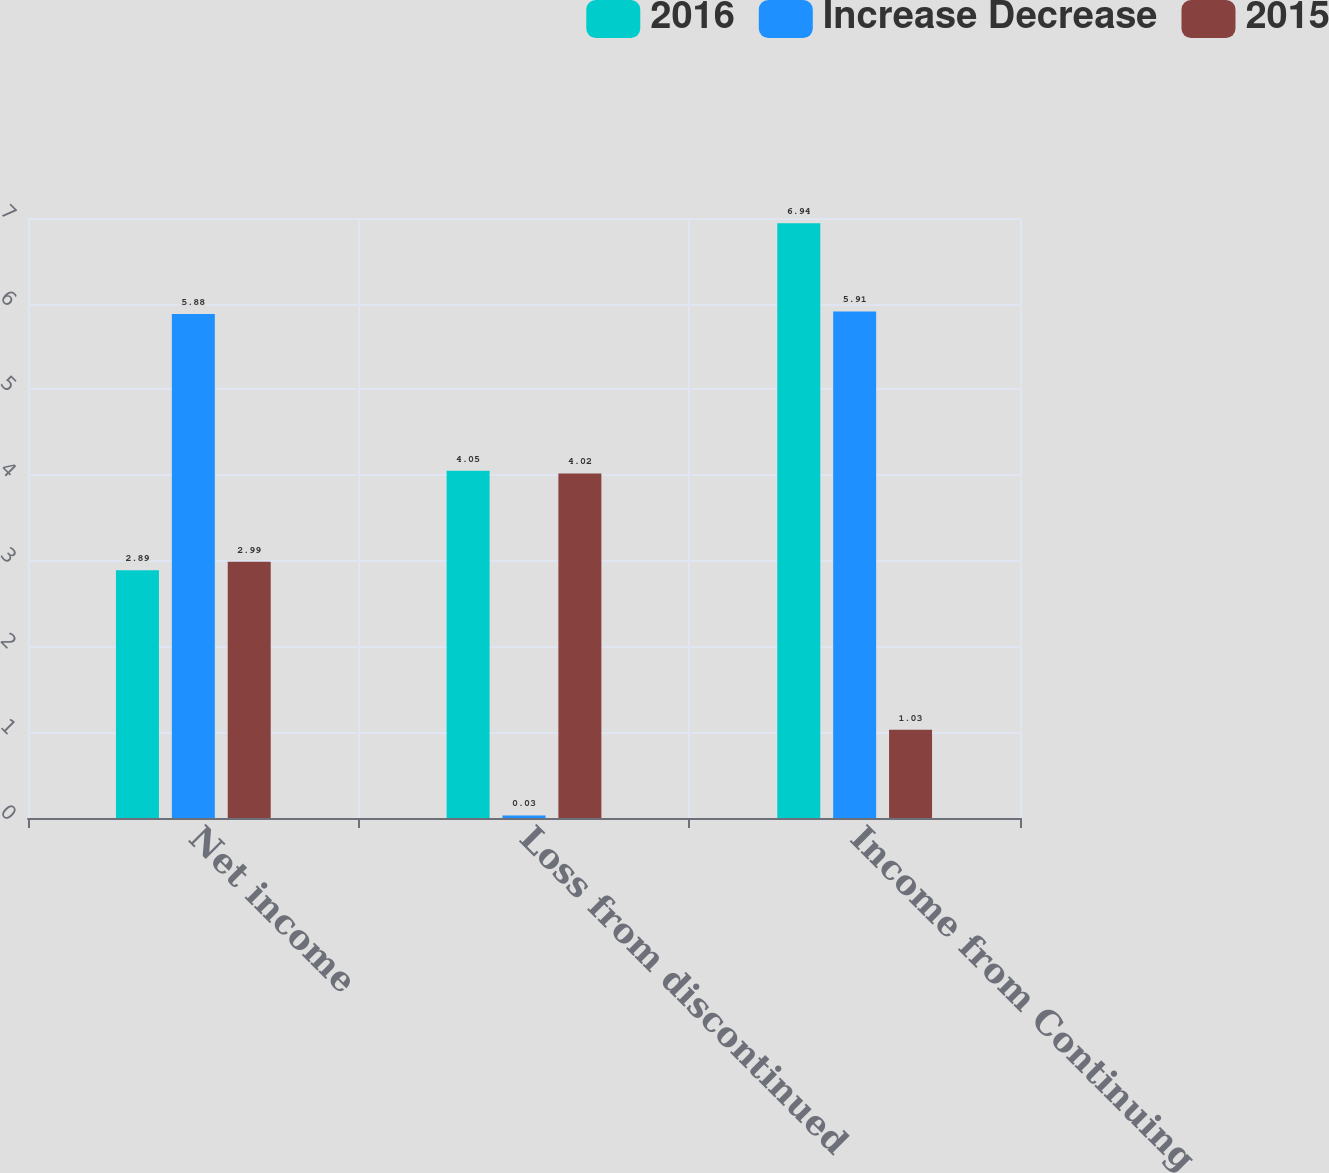<chart> <loc_0><loc_0><loc_500><loc_500><stacked_bar_chart><ecel><fcel>Net income<fcel>Loss from discontinued<fcel>Income from Continuing<nl><fcel>2016<fcel>2.89<fcel>4.05<fcel>6.94<nl><fcel>Increase Decrease<fcel>5.88<fcel>0.03<fcel>5.91<nl><fcel>2015<fcel>2.99<fcel>4.02<fcel>1.03<nl></chart> 